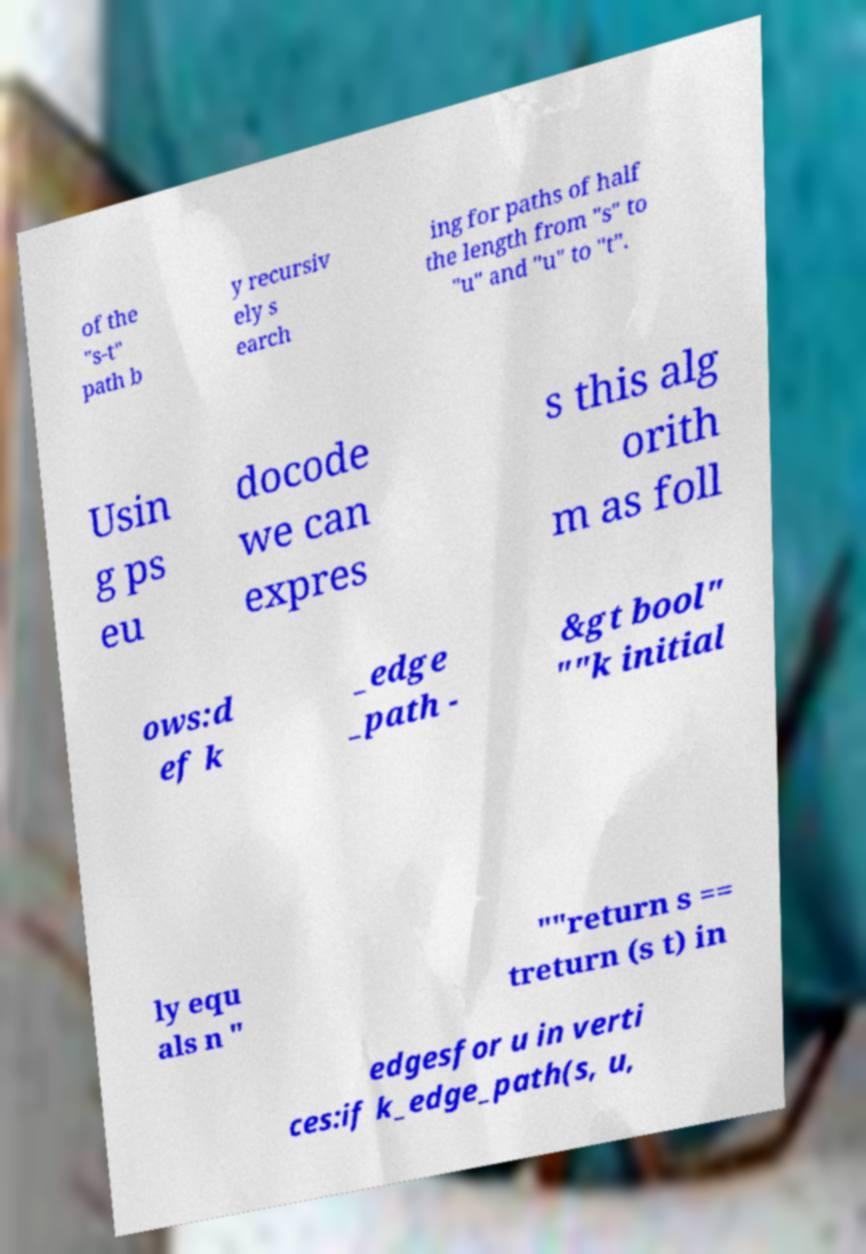Could you extract and type out the text from this image? of the "s-t" path b y recursiv ely s earch ing for paths of half the length from "s" to "u" and "u" to "t". Usin g ps eu docode we can expres s this alg orith m as foll ows:d ef k _edge _path - &gt bool" ""k initial ly equ als n " ""return s == treturn (s t) in edgesfor u in verti ces:if k_edge_path(s, u, 